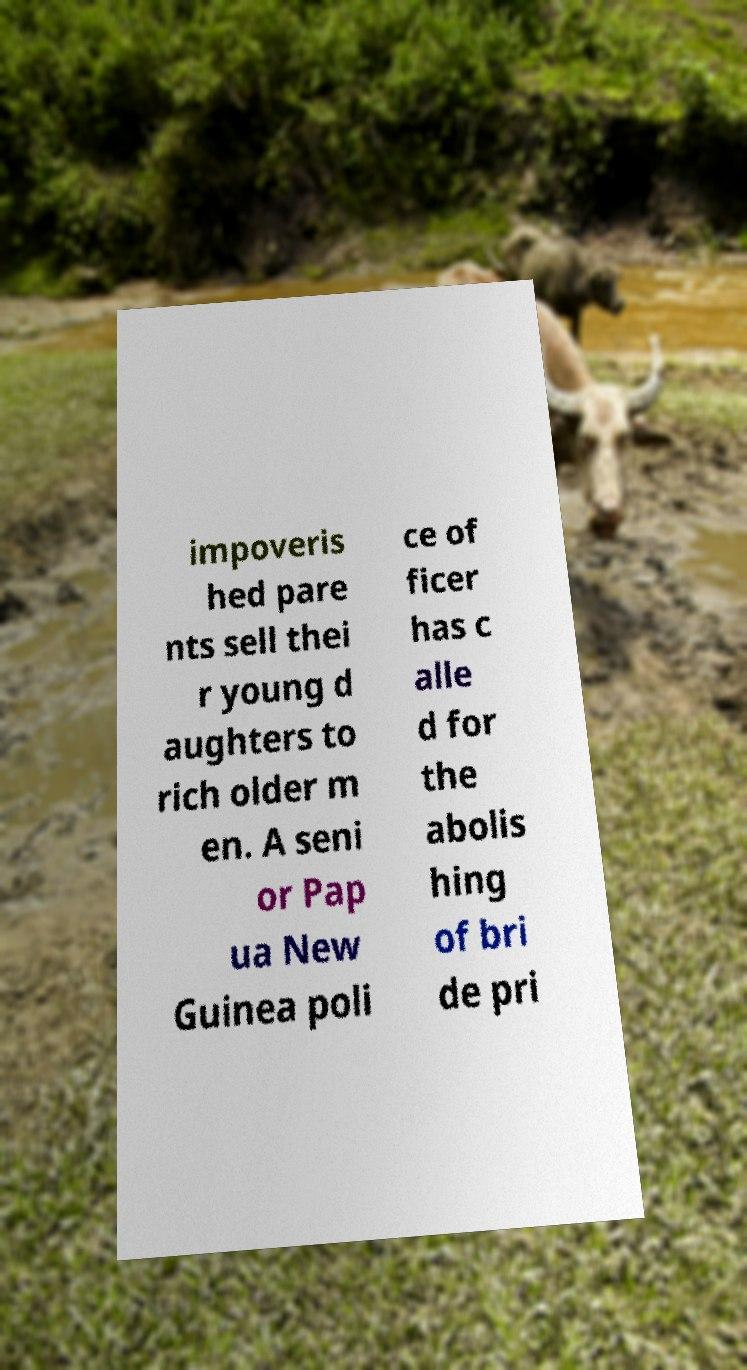For documentation purposes, I need the text within this image transcribed. Could you provide that? impoveris hed pare nts sell thei r young d aughters to rich older m en. A seni or Pap ua New Guinea poli ce of ficer has c alle d for the abolis hing of bri de pri 